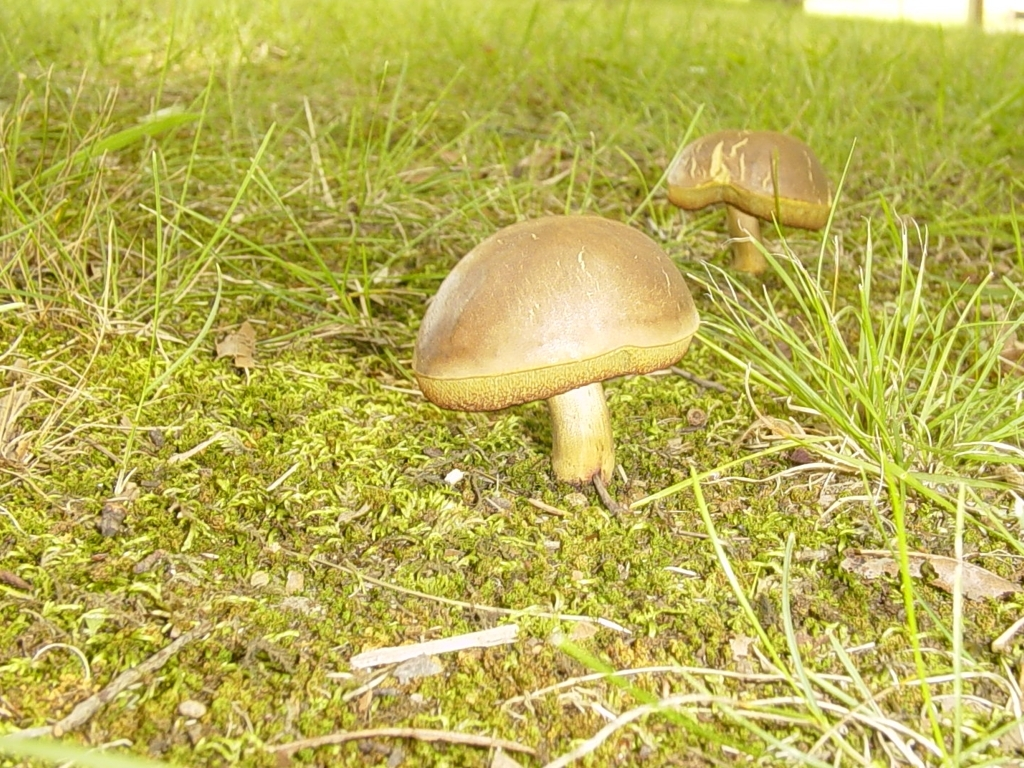Considering the time of day, what can you tell about the lighting in this photo? The lighting in the photo suggests it may have been taken during the daytime, indicated by the bright and natural light casting on the mushrooms and the surrounding environment. There are no harsh shadows, so it might be on a day with soft, diffused sunlight, possibly an overcast sky, which brings out the colors and textures without creating intense contrasts. 